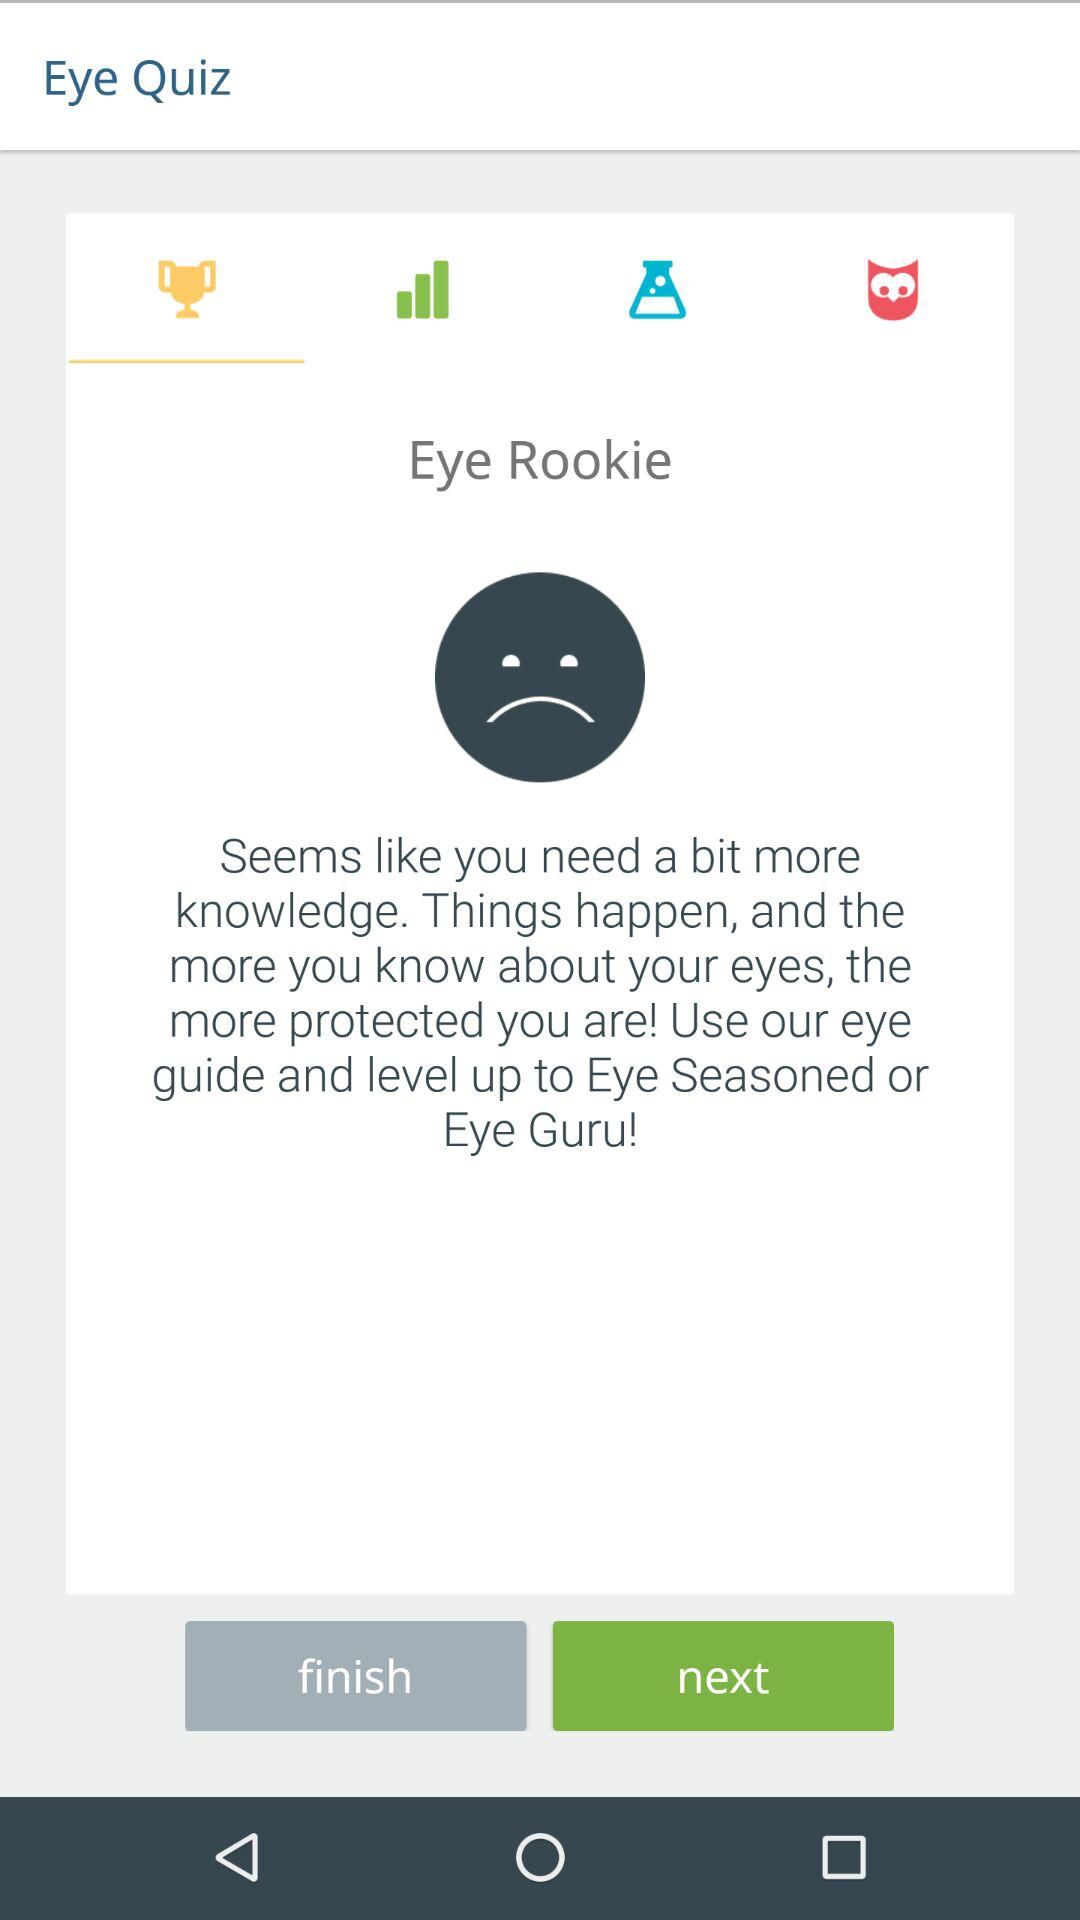What is the name of the application? The name of the application is "Eye Quiz". 